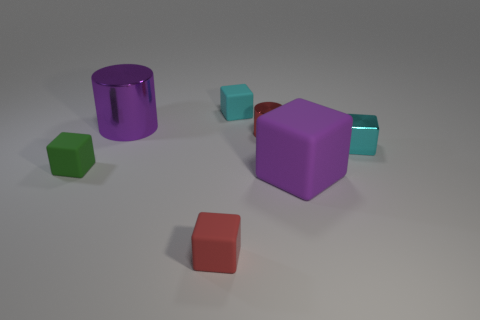Subtract all green blocks. How many blocks are left? 4 Subtract all metallic cubes. How many cubes are left? 4 Subtract all yellow blocks. Subtract all brown spheres. How many blocks are left? 5 Add 1 red matte cubes. How many objects exist? 8 Subtract all cylinders. How many objects are left? 5 Add 5 big brown matte cubes. How many big brown matte cubes exist? 5 Subtract 2 cyan blocks. How many objects are left? 5 Subtract all shiny objects. Subtract all cyan objects. How many objects are left? 2 Add 2 small green rubber objects. How many small green rubber objects are left? 3 